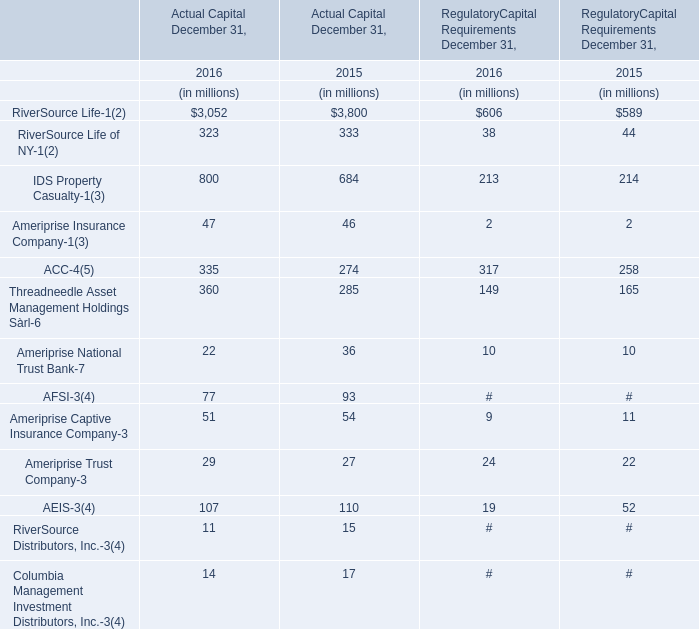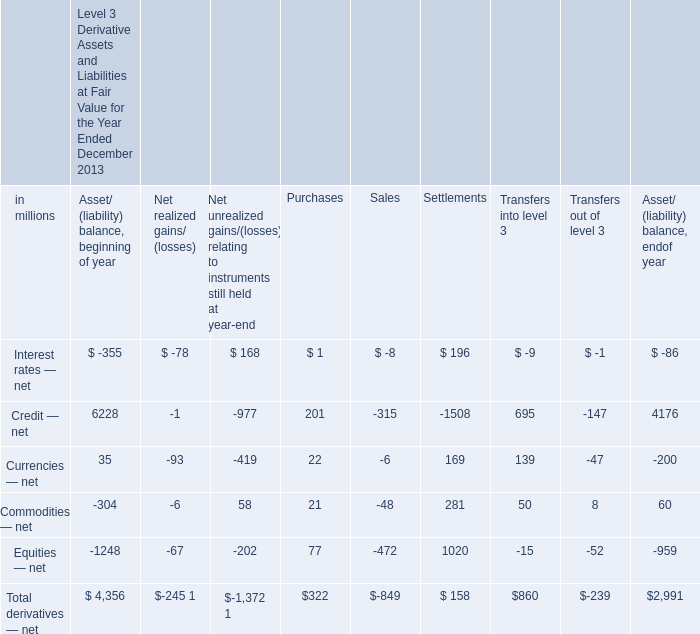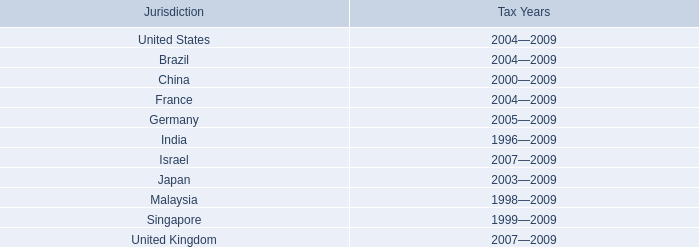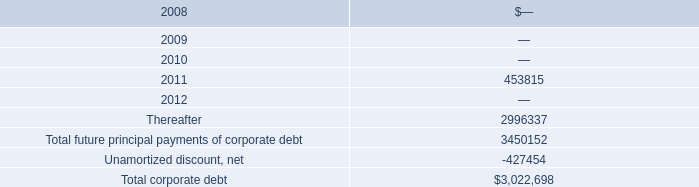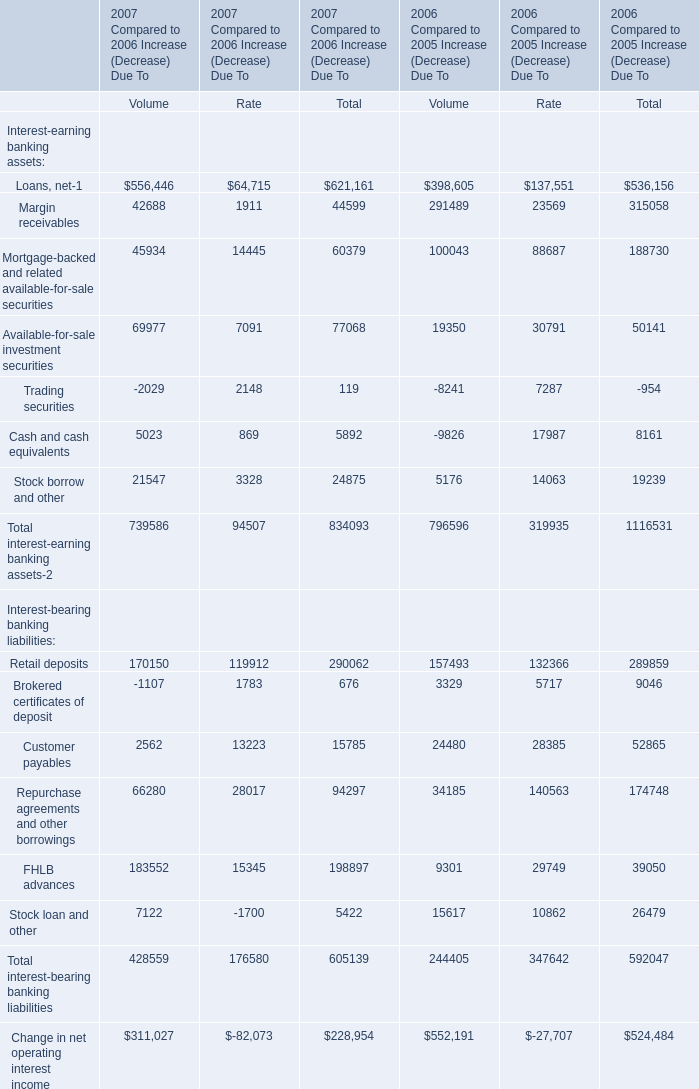What's the total amount of Actual Capital excluding RiverSource Life and RiverSource Life of NY in 2016? (in millions) 
Computations: (((((((((47 + 335) + 360) + 22) + 77) + 51) + 29) + 107) + 11) + 14)
Answer: 1053.0. 